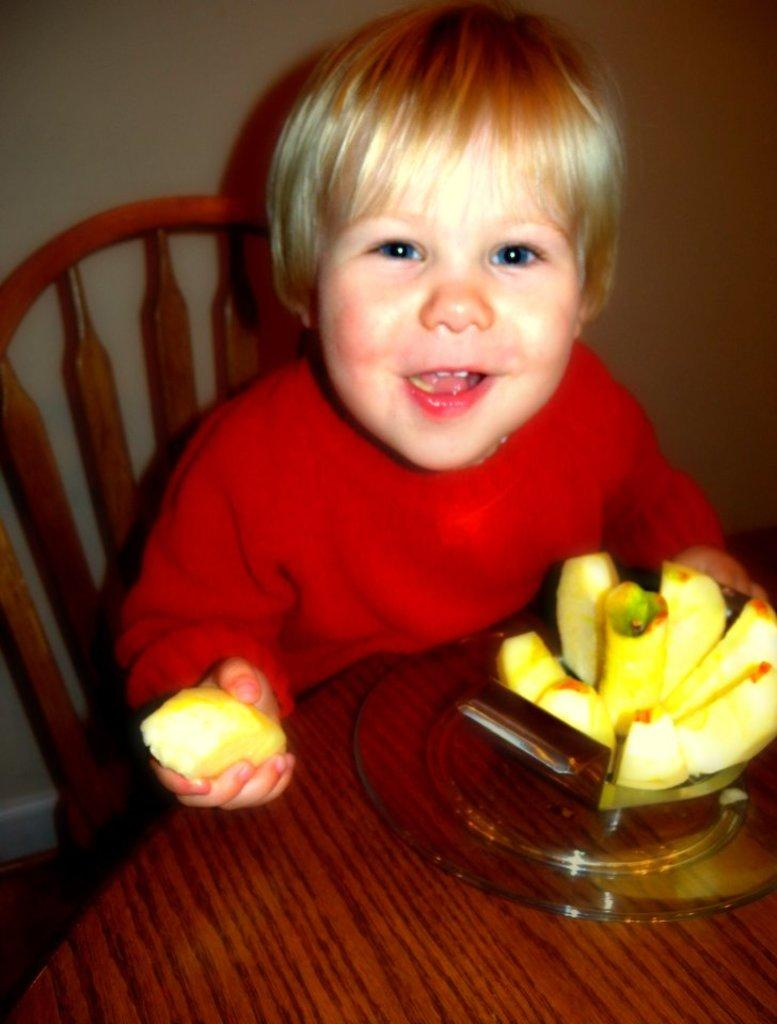What is the main subject of the image? The main subject of the image is a kid. What is the kid wearing in the image? The kid is wearing a red dress in the image. What can be seen on a table in the image? There are fruits on a table in the image. What is visible in the background of the image? There is a chair and a wall in the background of the image. Is the kid wearing a crown in the image? No, the kid is not wearing a crown in the image. What type of plant can be seen growing on the wall in the image? There is no plant growing on the wall in the image. 